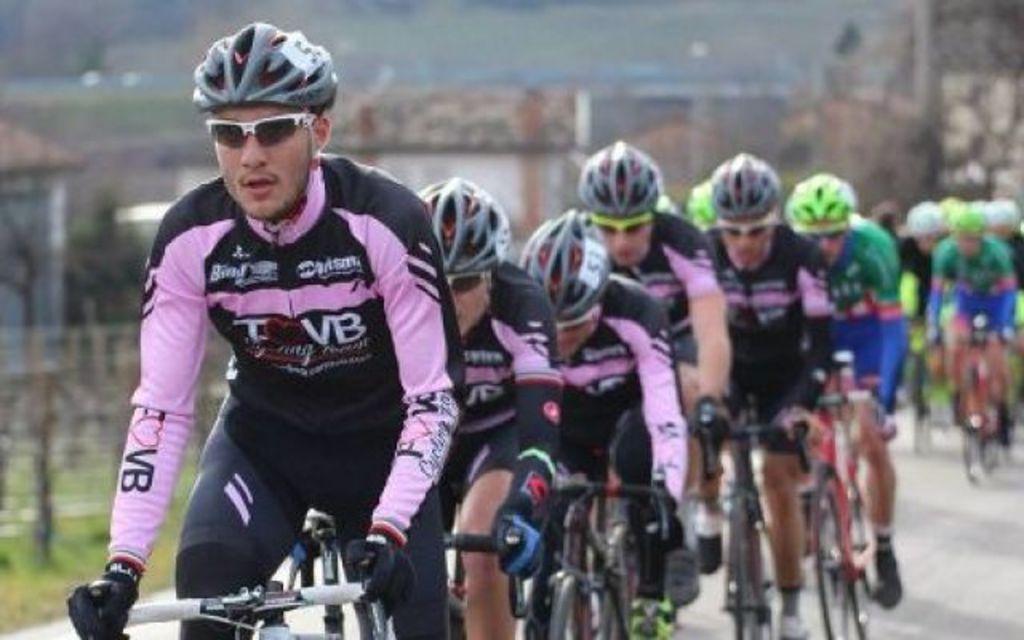Can you describe this image briefly? In this image I can see number of people are sitting on their bicycles. I can also see they all are wearing sports wear, helmets, shades and gloves. I can also see something is written on their dresses and I can see this image is little bit blurry from background. 